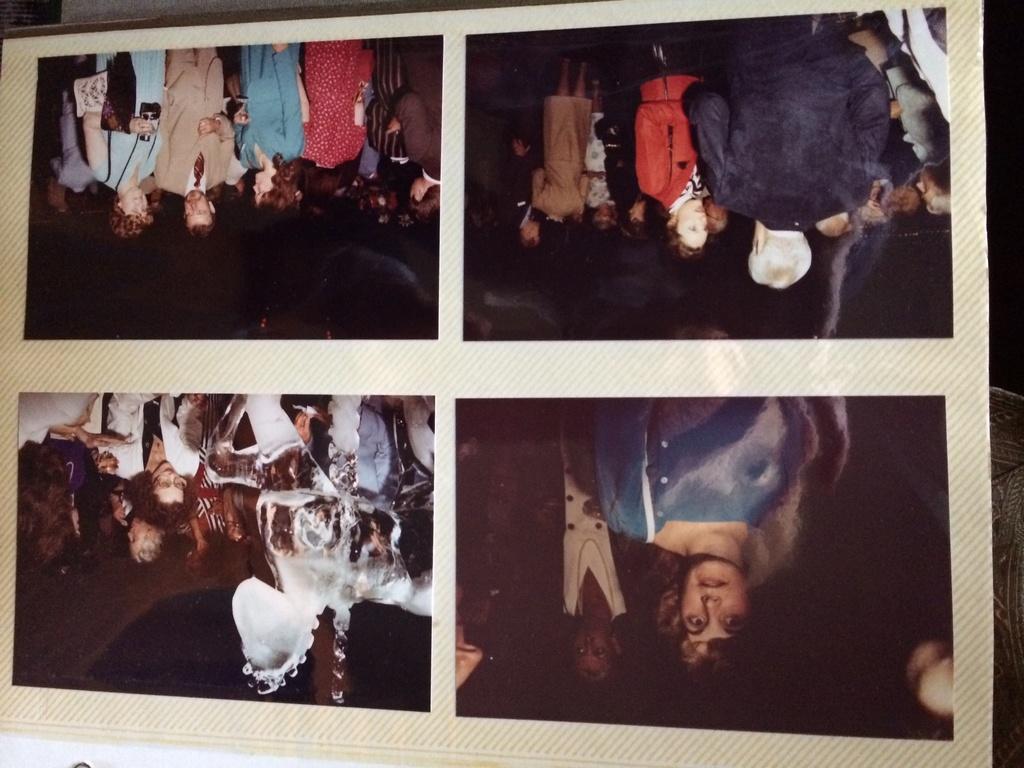In one or two sentences, can you explain what this image depicts? It is the picture of an album and the album has four photographs. 